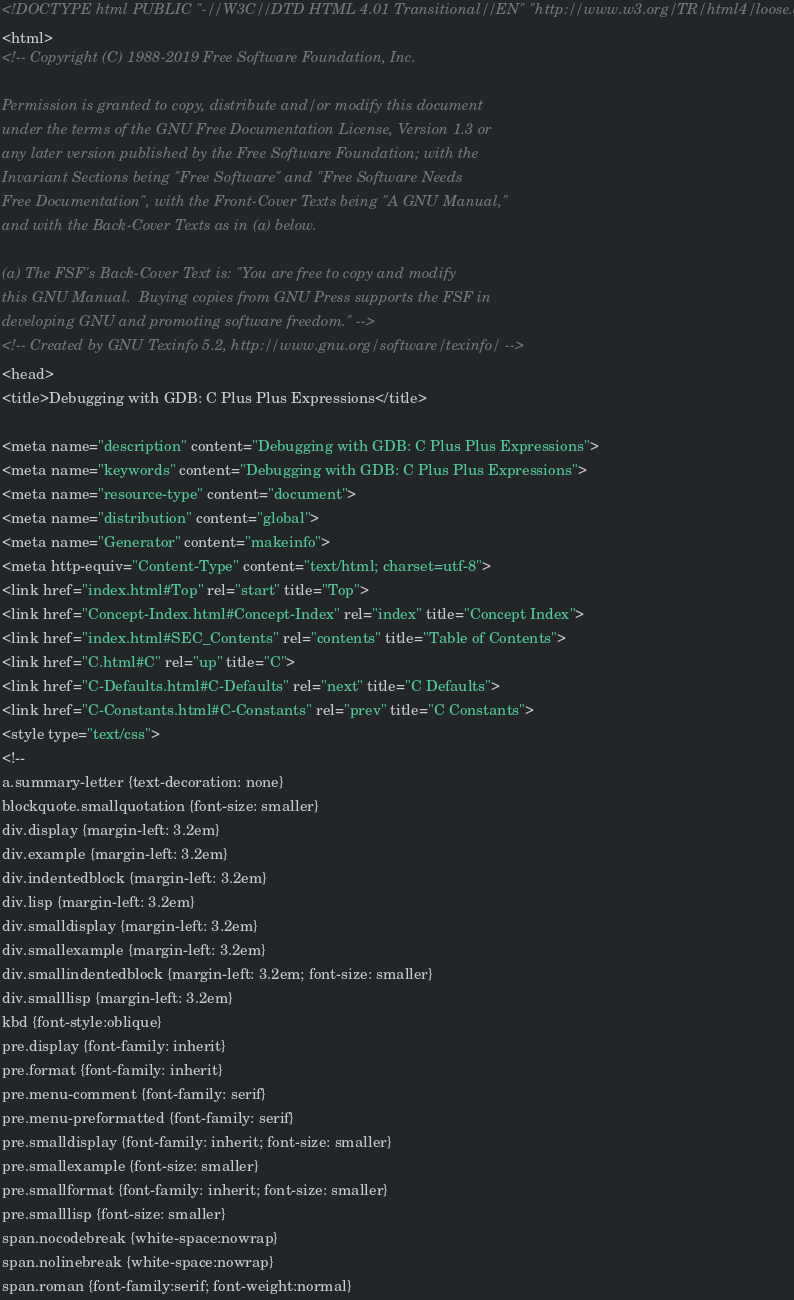Convert code to text. <code><loc_0><loc_0><loc_500><loc_500><_HTML_><!DOCTYPE html PUBLIC "-//W3C//DTD HTML 4.01 Transitional//EN" "http://www.w3.org/TR/html4/loose.dtd">
<html>
<!-- Copyright (C) 1988-2019 Free Software Foundation, Inc.

Permission is granted to copy, distribute and/or modify this document
under the terms of the GNU Free Documentation License, Version 1.3 or
any later version published by the Free Software Foundation; with the
Invariant Sections being "Free Software" and "Free Software Needs
Free Documentation", with the Front-Cover Texts being "A GNU Manual,"
and with the Back-Cover Texts as in (a) below.

(a) The FSF's Back-Cover Text is: "You are free to copy and modify
this GNU Manual.  Buying copies from GNU Press supports the FSF in
developing GNU and promoting software freedom." -->
<!-- Created by GNU Texinfo 5.2, http://www.gnu.org/software/texinfo/ -->
<head>
<title>Debugging with GDB: C Plus Plus Expressions</title>

<meta name="description" content="Debugging with GDB: C Plus Plus Expressions">
<meta name="keywords" content="Debugging with GDB: C Plus Plus Expressions">
<meta name="resource-type" content="document">
<meta name="distribution" content="global">
<meta name="Generator" content="makeinfo">
<meta http-equiv="Content-Type" content="text/html; charset=utf-8">
<link href="index.html#Top" rel="start" title="Top">
<link href="Concept-Index.html#Concept-Index" rel="index" title="Concept Index">
<link href="index.html#SEC_Contents" rel="contents" title="Table of Contents">
<link href="C.html#C" rel="up" title="C">
<link href="C-Defaults.html#C-Defaults" rel="next" title="C Defaults">
<link href="C-Constants.html#C-Constants" rel="prev" title="C Constants">
<style type="text/css">
<!--
a.summary-letter {text-decoration: none}
blockquote.smallquotation {font-size: smaller}
div.display {margin-left: 3.2em}
div.example {margin-left: 3.2em}
div.indentedblock {margin-left: 3.2em}
div.lisp {margin-left: 3.2em}
div.smalldisplay {margin-left: 3.2em}
div.smallexample {margin-left: 3.2em}
div.smallindentedblock {margin-left: 3.2em; font-size: smaller}
div.smalllisp {margin-left: 3.2em}
kbd {font-style:oblique}
pre.display {font-family: inherit}
pre.format {font-family: inherit}
pre.menu-comment {font-family: serif}
pre.menu-preformatted {font-family: serif}
pre.smalldisplay {font-family: inherit; font-size: smaller}
pre.smallexample {font-size: smaller}
pre.smallformat {font-family: inherit; font-size: smaller}
pre.smalllisp {font-size: smaller}
span.nocodebreak {white-space:nowrap}
span.nolinebreak {white-space:nowrap}
span.roman {font-family:serif; font-weight:normal}</code> 